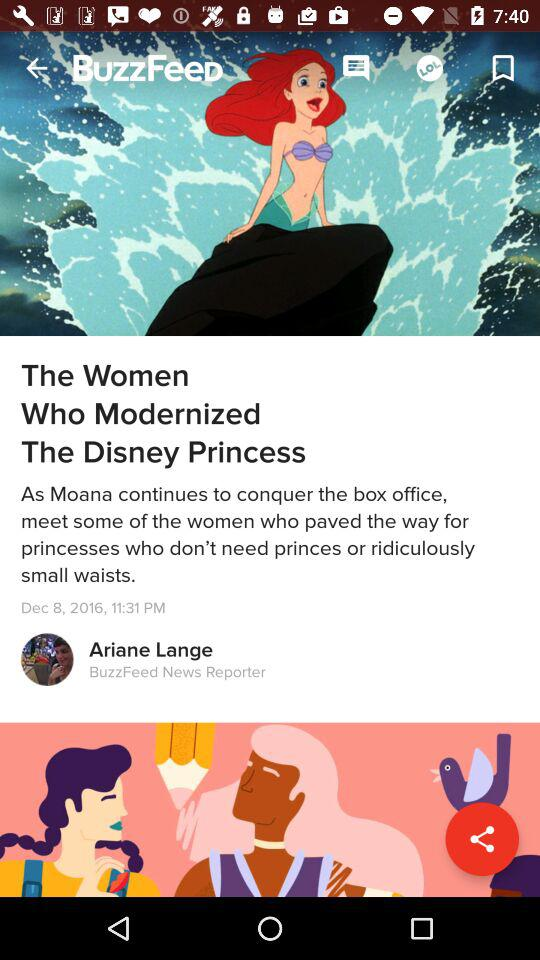What's the designation of the author? The designation of the author is BuzzFeed News Reporter. 